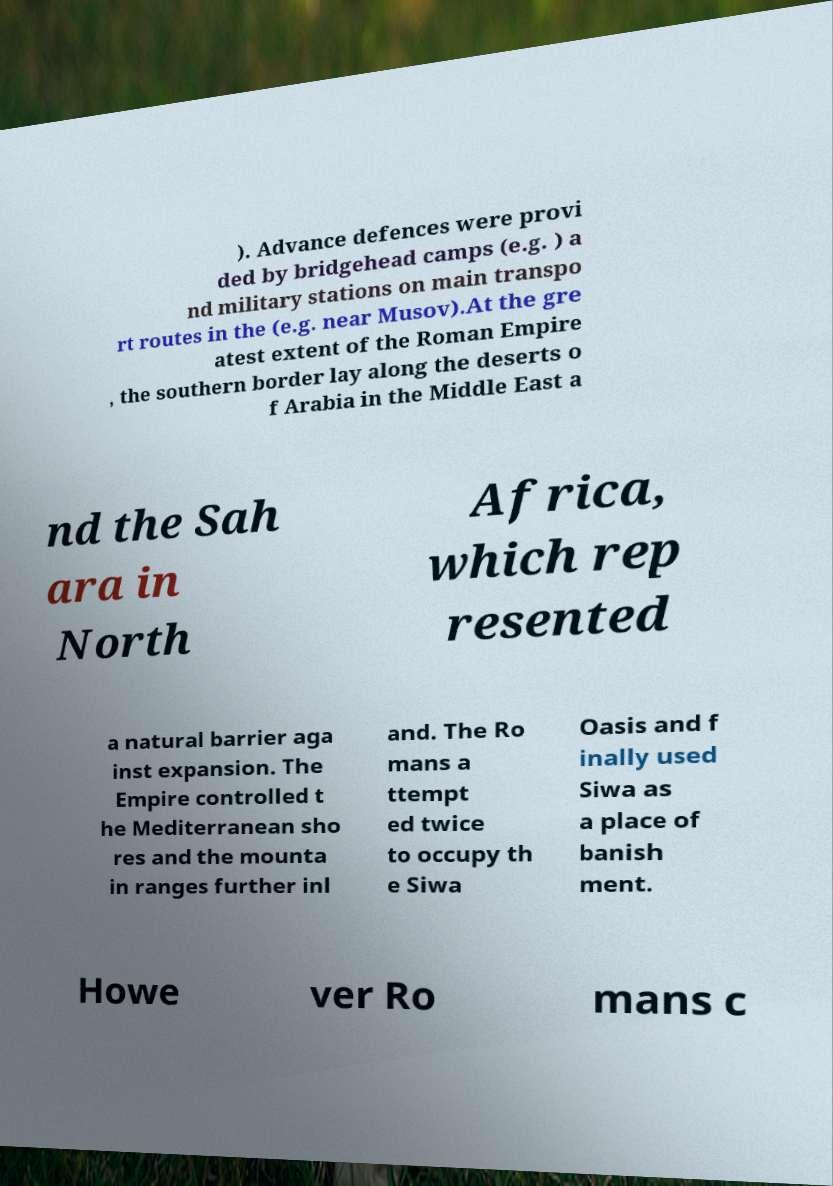Can you read and provide the text displayed in the image?This photo seems to have some interesting text. Can you extract and type it out for me? ). Advance defences were provi ded by bridgehead camps (e.g. ) a nd military stations on main transpo rt routes in the (e.g. near Musov).At the gre atest extent of the Roman Empire , the southern border lay along the deserts o f Arabia in the Middle East a nd the Sah ara in North Africa, which rep resented a natural barrier aga inst expansion. The Empire controlled t he Mediterranean sho res and the mounta in ranges further inl and. The Ro mans a ttempt ed twice to occupy th e Siwa Oasis and f inally used Siwa as a place of banish ment. Howe ver Ro mans c 